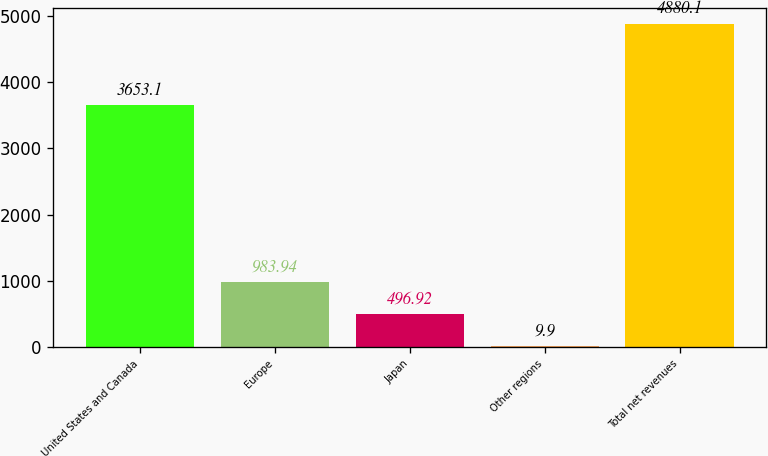Convert chart to OTSL. <chart><loc_0><loc_0><loc_500><loc_500><bar_chart><fcel>United States and Canada<fcel>Europe<fcel>Japan<fcel>Other regions<fcel>Total net revenues<nl><fcel>3653.1<fcel>983.94<fcel>496.92<fcel>9.9<fcel>4880.1<nl></chart> 